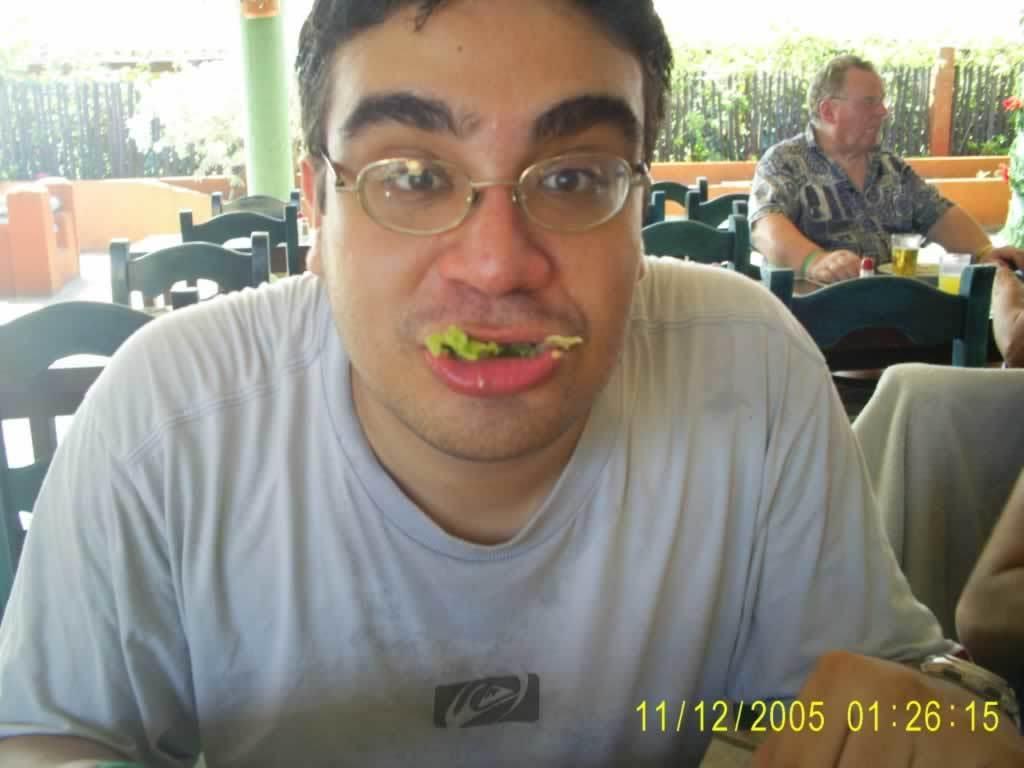Could you give a brief overview of what you see in this image? In this picture there is a man in the center of the image, he is eating and and there are chairs, other people and a pillar in the background area of the image and there are plants and a boundary at the top side of the image. 